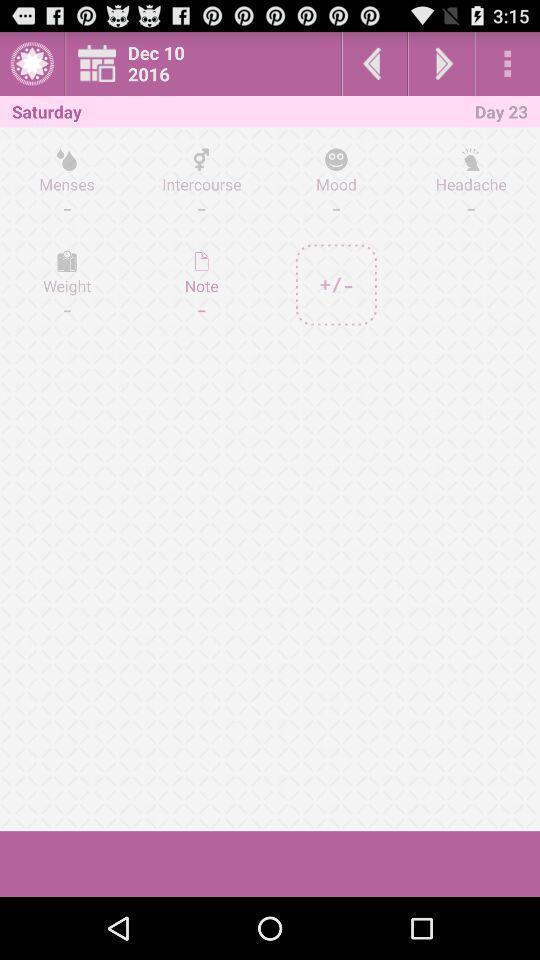Describe the visual elements of this screenshot. Screen shows health options in a health application. 